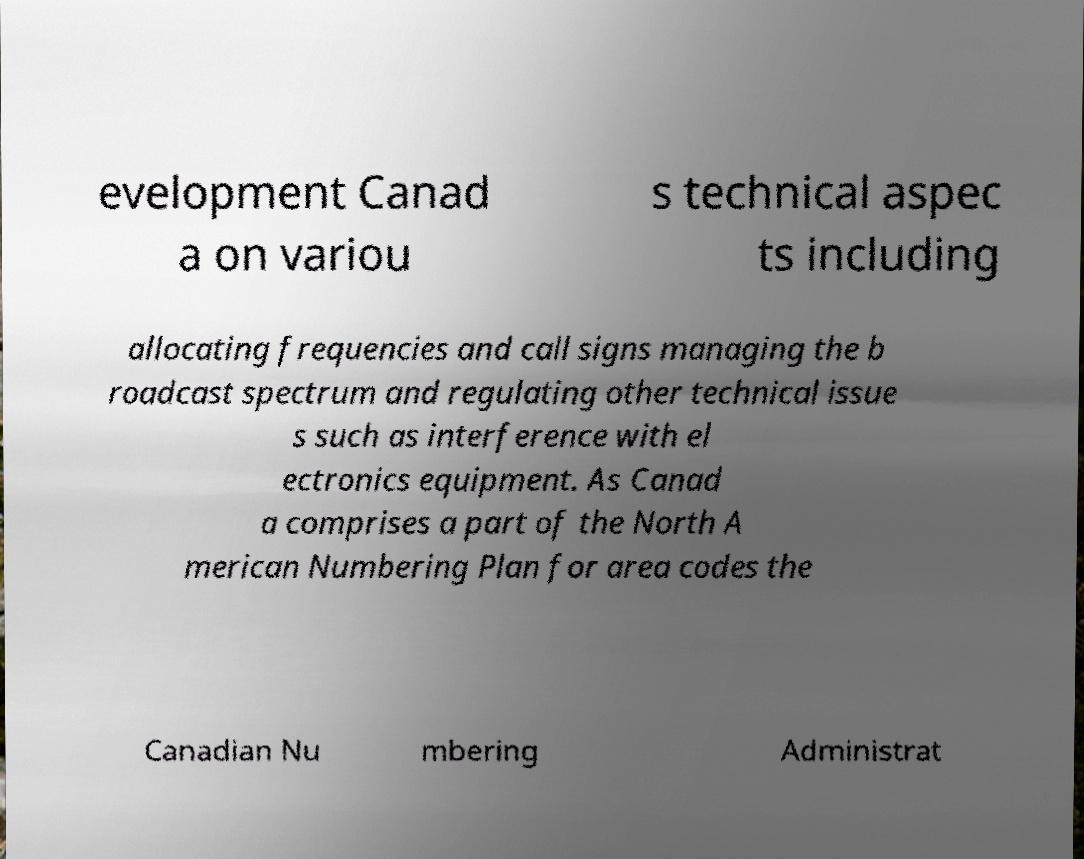Could you assist in decoding the text presented in this image and type it out clearly? evelopment Canad a on variou s technical aspec ts including allocating frequencies and call signs managing the b roadcast spectrum and regulating other technical issue s such as interference with el ectronics equipment. As Canad a comprises a part of the North A merican Numbering Plan for area codes the Canadian Nu mbering Administrat 